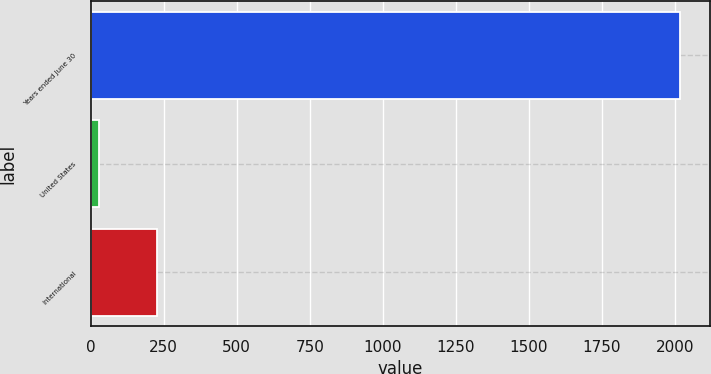Convert chart. <chart><loc_0><loc_0><loc_500><loc_500><bar_chart><fcel>Years ended June 30<fcel>United States<fcel>International<nl><fcel>2018<fcel>27.3<fcel>226.37<nl></chart> 